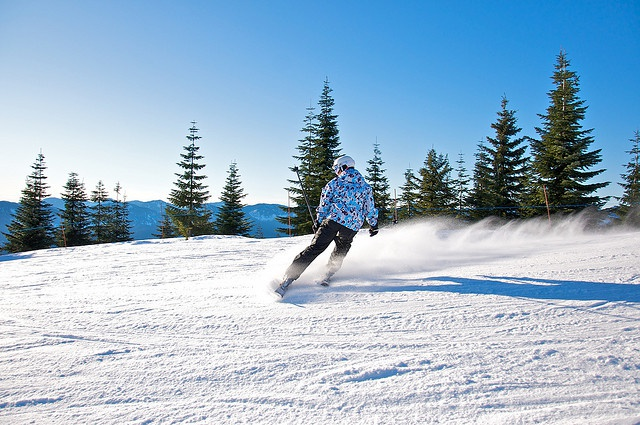Describe the objects in this image and their specific colors. I can see people in lightblue, black, lightgray, darkgray, and gray tones and skis in lightblue, gray, darkgray, and lightgray tones in this image. 